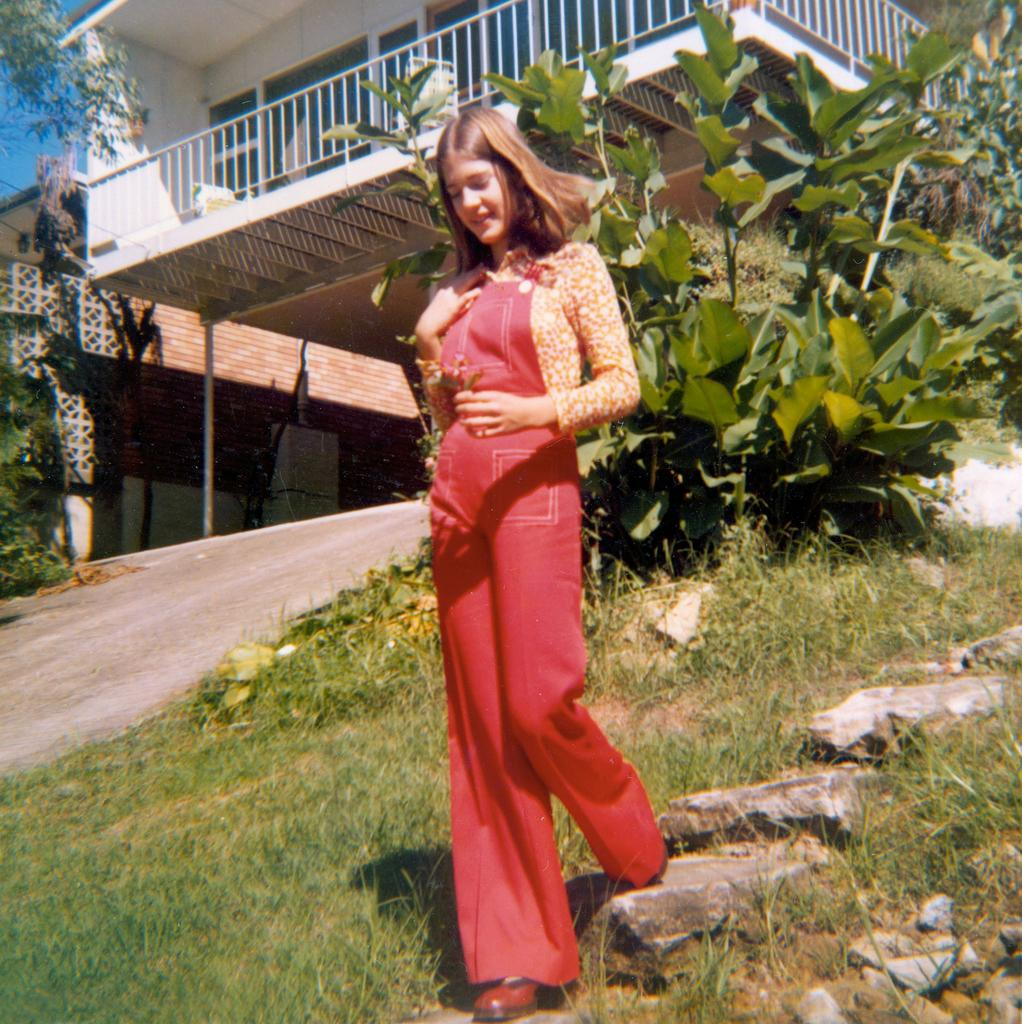What is the person in the image doing? The person is walking in the image. On what surface is the person walking? The person is walking on the ground. What can be seen in the background of the image? There is a house, a sidewalk, trees, plants, stones, and the sky visible in the background of the image. What color is the person's father's thought in the image? There is no person's father or thought present in the image. 